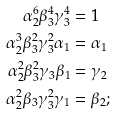Convert formula to latex. <formula><loc_0><loc_0><loc_500><loc_500>\alpha _ { 2 } ^ { 6 } \beta _ { 3 } ^ { 4 } \gamma _ { 3 } ^ { 4 } & = 1 \\ \alpha _ { 2 } ^ { 3 } \beta _ { 3 } ^ { 2 } \gamma _ { 3 } ^ { 2 } \alpha _ { 1 } & = \alpha _ { 1 } \\ \alpha _ { 2 } ^ { 2 } \beta _ { 3 } ^ { 2 } \gamma _ { 3 } \beta _ { 1 } & = \gamma _ { 2 } \\ \alpha _ { 2 } ^ { 2 } \beta _ { 3 } \gamma _ { 3 } ^ { 2 } \gamma _ { 1 } & = \beta _ { 2 } ;</formula> 